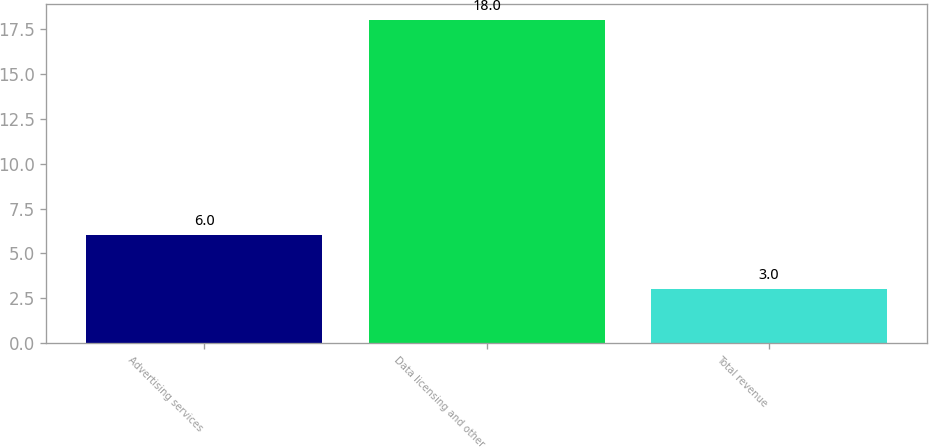Convert chart. <chart><loc_0><loc_0><loc_500><loc_500><bar_chart><fcel>Advertising services<fcel>Data licensing and other<fcel>Total revenue<nl><fcel>6<fcel>18<fcel>3<nl></chart> 